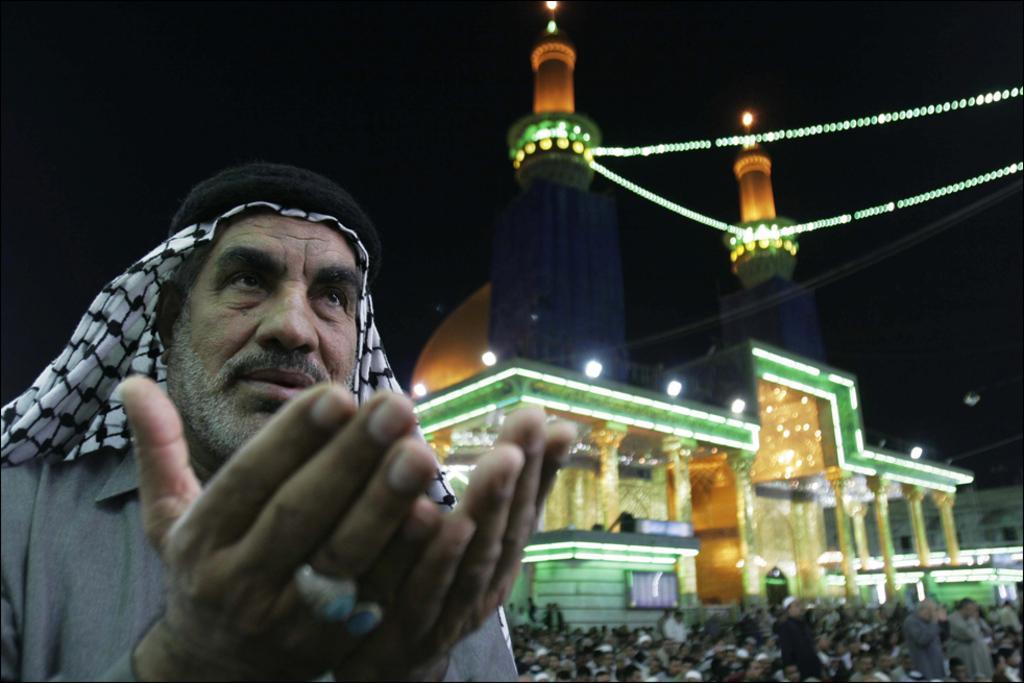How would you summarize this image in a sentence or two? In this image in front there is a person. Beside him there are a few other people. Behind them there are buildings. There are lights, pillars. In the background of the image there is sky. 